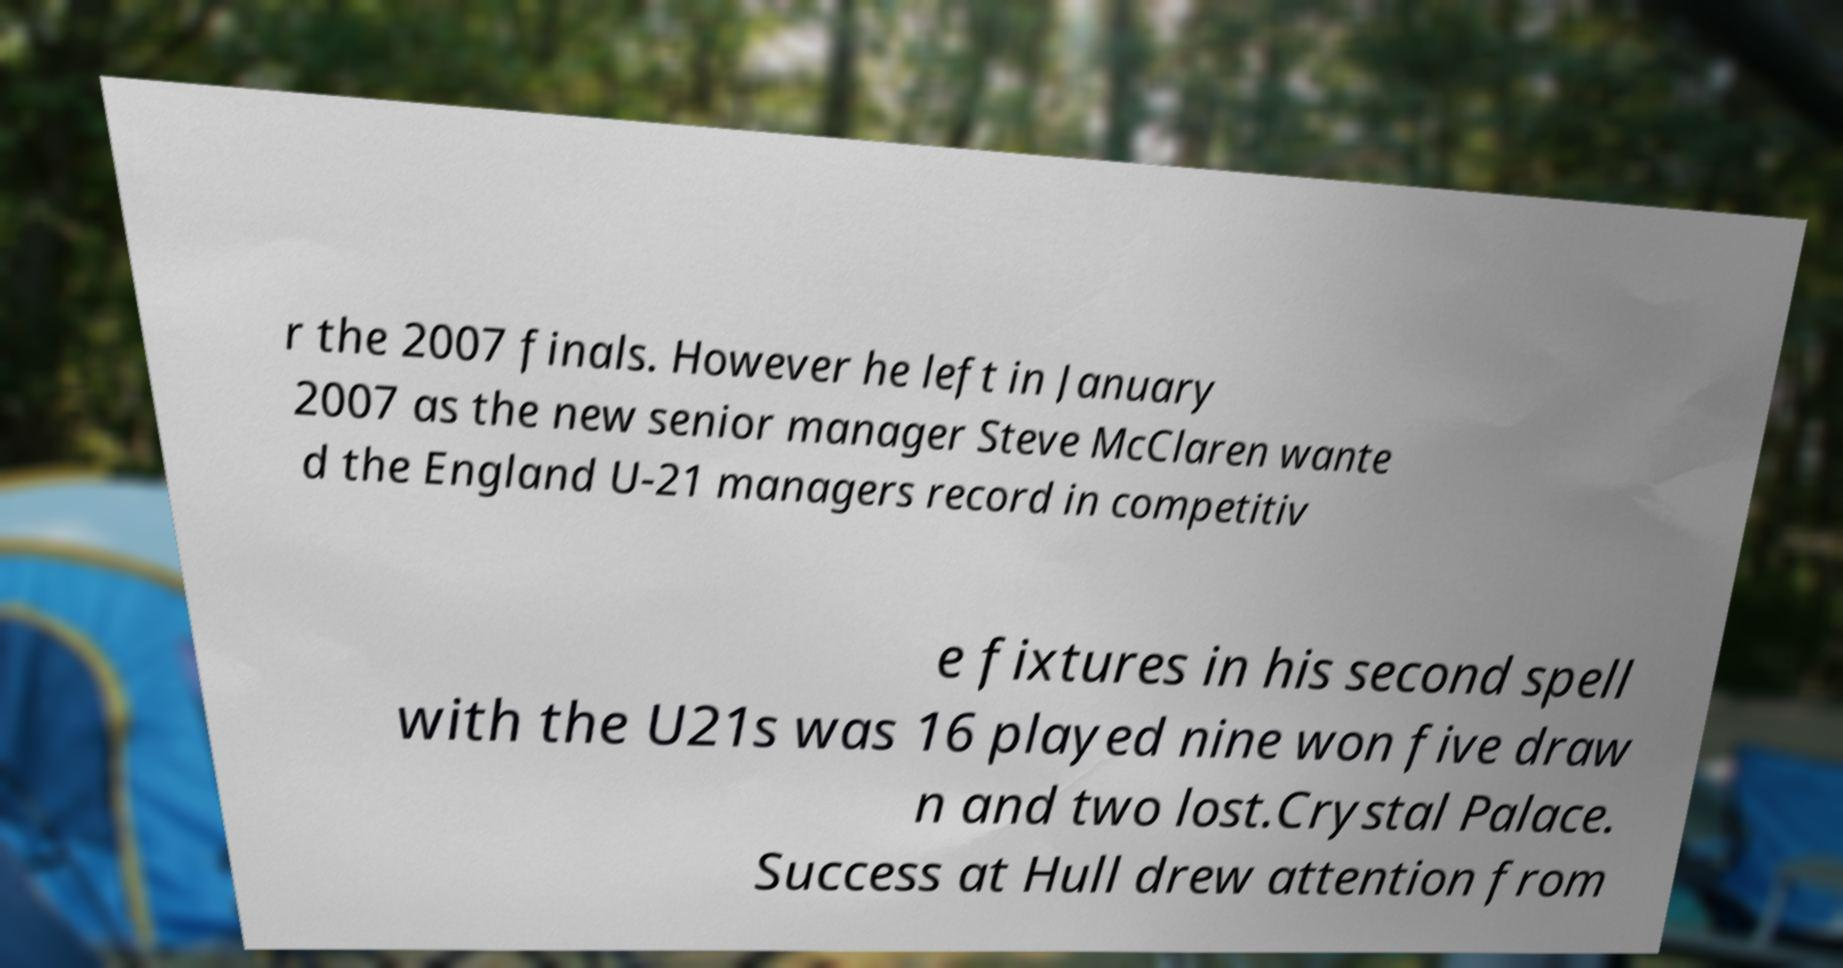What messages or text are displayed in this image? I need them in a readable, typed format. r the 2007 finals. However he left in January 2007 as the new senior manager Steve McClaren wante d the England U-21 managers record in competitiv e fixtures in his second spell with the U21s was 16 played nine won five draw n and two lost.Crystal Palace. Success at Hull drew attention from 